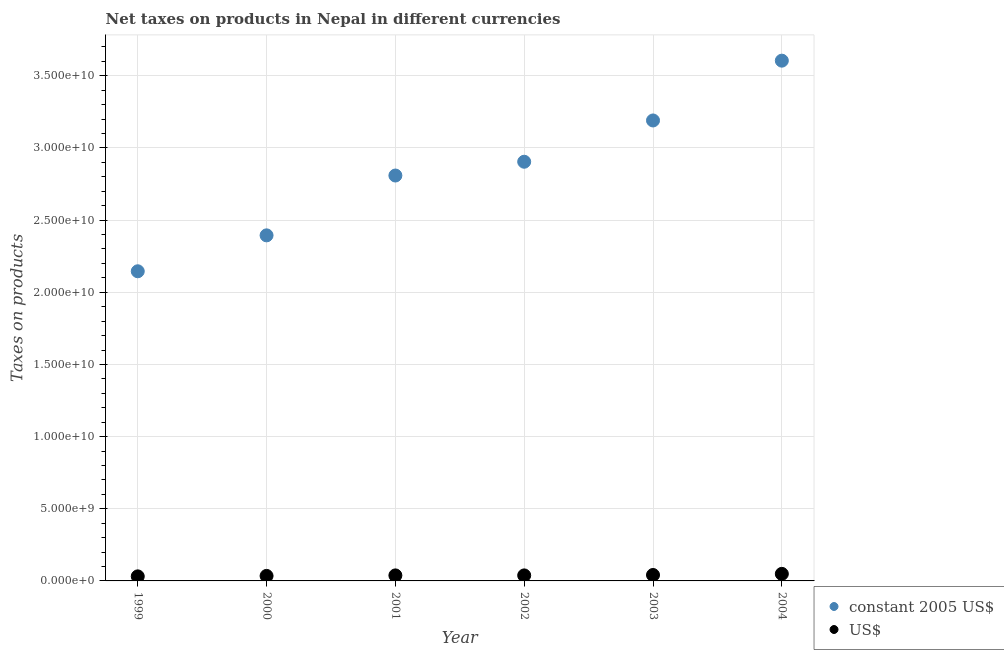Is the number of dotlines equal to the number of legend labels?
Give a very brief answer. Yes. What is the net taxes in constant 2005 us$ in 2001?
Make the answer very short. 2.81e+1. Across all years, what is the maximum net taxes in constant 2005 us$?
Your answer should be compact. 3.60e+1. Across all years, what is the minimum net taxes in us$?
Make the answer very short. 3.16e+08. In which year was the net taxes in constant 2005 us$ maximum?
Your answer should be very brief. 2004. What is the total net taxes in us$ in the graph?
Your answer should be very brief. 2.33e+09. What is the difference between the net taxes in us$ in 2002 and that in 2004?
Your answer should be very brief. -1.06e+08. What is the difference between the net taxes in constant 2005 us$ in 2000 and the net taxes in us$ in 2004?
Offer a terse response. 2.35e+1. What is the average net taxes in constant 2005 us$ per year?
Ensure brevity in your answer.  2.84e+1. In the year 2003, what is the difference between the net taxes in constant 2005 us$ and net taxes in us$?
Your answer should be compact. 3.15e+1. What is the ratio of the net taxes in us$ in 1999 to that in 2001?
Provide a short and direct response. 0.83. Is the net taxes in constant 2005 us$ in 2000 less than that in 2001?
Your answer should be compact. Yes. What is the difference between the highest and the second highest net taxes in us$?
Provide a succinct answer. 7.82e+07. What is the difference between the highest and the lowest net taxes in constant 2005 us$?
Offer a terse response. 1.46e+1. In how many years, is the net taxes in us$ greater than the average net taxes in us$ taken over all years?
Your answer should be very brief. 2. Is the sum of the net taxes in us$ in 1999 and 2002 greater than the maximum net taxes in constant 2005 us$ across all years?
Offer a terse response. No. Is the net taxes in us$ strictly greater than the net taxes in constant 2005 us$ over the years?
Provide a succinct answer. No. Is the net taxes in us$ strictly less than the net taxes in constant 2005 us$ over the years?
Offer a very short reply. Yes. How many years are there in the graph?
Make the answer very short. 6. Are the values on the major ticks of Y-axis written in scientific E-notation?
Your response must be concise. Yes. Where does the legend appear in the graph?
Your answer should be very brief. Bottom right. How are the legend labels stacked?
Keep it short and to the point. Vertical. What is the title of the graph?
Your answer should be compact. Net taxes on products in Nepal in different currencies. What is the label or title of the X-axis?
Provide a short and direct response. Year. What is the label or title of the Y-axis?
Offer a very short reply. Taxes on products. What is the Taxes on products in constant 2005 US$ in 1999?
Provide a short and direct response. 2.15e+1. What is the Taxes on products of US$ in 1999?
Provide a succinct answer. 3.16e+08. What is the Taxes on products of constant 2005 US$ in 2000?
Your response must be concise. 2.39e+1. What is the Taxes on products of US$ in 2000?
Keep it short and to the point. 3.47e+08. What is the Taxes on products in constant 2005 US$ in 2001?
Give a very brief answer. 2.81e+1. What is the Taxes on products of US$ in 2001?
Your answer should be very brief. 3.82e+08. What is the Taxes on products in constant 2005 US$ in 2002?
Provide a short and direct response. 2.90e+1. What is the Taxes on products in US$ in 2002?
Provide a succinct answer. 3.83e+08. What is the Taxes on products of constant 2005 US$ in 2003?
Provide a succinct answer. 3.19e+1. What is the Taxes on products of US$ in 2003?
Give a very brief answer. 4.10e+08. What is the Taxes on products in constant 2005 US$ in 2004?
Your answer should be compact. 3.60e+1. What is the Taxes on products of US$ in 2004?
Give a very brief answer. 4.89e+08. Across all years, what is the maximum Taxes on products of constant 2005 US$?
Give a very brief answer. 3.60e+1. Across all years, what is the maximum Taxes on products of US$?
Ensure brevity in your answer.  4.89e+08. Across all years, what is the minimum Taxes on products in constant 2005 US$?
Ensure brevity in your answer.  2.15e+1. Across all years, what is the minimum Taxes on products in US$?
Offer a very short reply. 3.16e+08. What is the total Taxes on products of constant 2005 US$ in the graph?
Your response must be concise. 1.70e+11. What is the total Taxes on products in US$ in the graph?
Your answer should be compact. 2.33e+09. What is the difference between the Taxes on products of constant 2005 US$ in 1999 and that in 2000?
Provide a short and direct response. -2.49e+09. What is the difference between the Taxes on products in US$ in 1999 and that in 2000?
Keep it short and to the point. -3.09e+07. What is the difference between the Taxes on products of constant 2005 US$ in 1999 and that in 2001?
Ensure brevity in your answer.  -6.64e+09. What is the difference between the Taxes on products in US$ in 1999 and that in 2001?
Keep it short and to the point. -6.64e+07. What is the difference between the Taxes on products in constant 2005 US$ in 1999 and that in 2002?
Your answer should be compact. -7.59e+09. What is the difference between the Taxes on products in US$ in 1999 and that in 2002?
Provide a succinct answer. -6.68e+07. What is the difference between the Taxes on products in constant 2005 US$ in 1999 and that in 2003?
Your answer should be very brief. -1.04e+1. What is the difference between the Taxes on products in US$ in 1999 and that in 2003?
Make the answer very short. -9.46e+07. What is the difference between the Taxes on products in constant 2005 US$ in 1999 and that in 2004?
Your response must be concise. -1.46e+1. What is the difference between the Taxes on products of US$ in 1999 and that in 2004?
Offer a terse response. -1.73e+08. What is the difference between the Taxes on products in constant 2005 US$ in 2000 and that in 2001?
Provide a short and direct response. -4.15e+09. What is the difference between the Taxes on products in US$ in 2000 and that in 2001?
Offer a terse response. -3.55e+07. What is the difference between the Taxes on products of constant 2005 US$ in 2000 and that in 2002?
Make the answer very short. -5.10e+09. What is the difference between the Taxes on products of US$ in 2000 and that in 2002?
Make the answer very short. -3.59e+07. What is the difference between the Taxes on products of constant 2005 US$ in 2000 and that in 2003?
Give a very brief answer. -7.96e+09. What is the difference between the Taxes on products of US$ in 2000 and that in 2003?
Your response must be concise. -6.37e+07. What is the difference between the Taxes on products of constant 2005 US$ in 2000 and that in 2004?
Your response must be concise. -1.21e+1. What is the difference between the Taxes on products of US$ in 2000 and that in 2004?
Provide a short and direct response. -1.42e+08. What is the difference between the Taxes on products in constant 2005 US$ in 2001 and that in 2002?
Ensure brevity in your answer.  -9.55e+08. What is the difference between the Taxes on products of US$ in 2001 and that in 2002?
Offer a terse response. -3.46e+05. What is the difference between the Taxes on products in constant 2005 US$ in 2001 and that in 2003?
Your answer should be very brief. -3.82e+09. What is the difference between the Taxes on products of US$ in 2001 and that in 2003?
Your response must be concise. -2.81e+07. What is the difference between the Taxes on products in constant 2005 US$ in 2001 and that in 2004?
Offer a very short reply. -7.96e+09. What is the difference between the Taxes on products in US$ in 2001 and that in 2004?
Offer a very short reply. -1.06e+08. What is the difference between the Taxes on products in constant 2005 US$ in 2002 and that in 2003?
Your response must be concise. -2.86e+09. What is the difference between the Taxes on products of US$ in 2002 and that in 2003?
Give a very brief answer. -2.78e+07. What is the difference between the Taxes on products in constant 2005 US$ in 2002 and that in 2004?
Your answer should be compact. -7.00e+09. What is the difference between the Taxes on products of US$ in 2002 and that in 2004?
Give a very brief answer. -1.06e+08. What is the difference between the Taxes on products of constant 2005 US$ in 2003 and that in 2004?
Make the answer very short. -4.14e+09. What is the difference between the Taxes on products of US$ in 2003 and that in 2004?
Provide a succinct answer. -7.82e+07. What is the difference between the Taxes on products of constant 2005 US$ in 1999 and the Taxes on products of US$ in 2000?
Make the answer very short. 2.11e+1. What is the difference between the Taxes on products in constant 2005 US$ in 1999 and the Taxes on products in US$ in 2001?
Your answer should be very brief. 2.11e+1. What is the difference between the Taxes on products of constant 2005 US$ in 1999 and the Taxes on products of US$ in 2002?
Make the answer very short. 2.11e+1. What is the difference between the Taxes on products in constant 2005 US$ in 1999 and the Taxes on products in US$ in 2003?
Make the answer very short. 2.10e+1. What is the difference between the Taxes on products of constant 2005 US$ in 1999 and the Taxes on products of US$ in 2004?
Keep it short and to the point. 2.10e+1. What is the difference between the Taxes on products of constant 2005 US$ in 2000 and the Taxes on products of US$ in 2001?
Give a very brief answer. 2.36e+1. What is the difference between the Taxes on products of constant 2005 US$ in 2000 and the Taxes on products of US$ in 2002?
Offer a terse response. 2.36e+1. What is the difference between the Taxes on products in constant 2005 US$ in 2000 and the Taxes on products in US$ in 2003?
Your response must be concise. 2.35e+1. What is the difference between the Taxes on products in constant 2005 US$ in 2000 and the Taxes on products in US$ in 2004?
Provide a succinct answer. 2.35e+1. What is the difference between the Taxes on products of constant 2005 US$ in 2001 and the Taxes on products of US$ in 2002?
Your answer should be compact. 2.77e+1. What is the difference between the Taxes on products of constant 2005 US$ in 2001 and the Taxes on products of US$ in 2003?
Ensure brevity in your answer.  2.77e+1. What is the difference between the Taxes on products in constant 2005 US$ in 2001 and the Taxes on products in US$ in 2004?
Provide a short and direct response. 2.76e+1. What is the difference between the Taxes on products in constant 2005 US$ in 2002 and the Taxes on products in US$ in 2003?
Offer a terse response. 2.86e+1. What is the difference between the Taxes on products in constant 2005 US$ in 2002 and the Taxes on products in US$ in 2004?
Your answer should be compact. 2.86e+1. What is the difference between the Taxes on products in constant 2005 US$ in 2003 and the Taxes on products in US$ in 2004?
Your answer should be very brief. 3.14e+1. What is the average Taxes on products in constant 2005 US$ per year?
Make the answer very short. 2.84e+1. What is the average Taxes on products in US$ per year?
Your answer should be compact. 3.88e+08. In the year 1999, what is the difference between the Taxes on products of constant 2005 US$ and Taxes on products of US$?
Keep it short and to the point. 2.11e+1. In the year 2000, what is the difference between the Taxes on products of constant 2005 US$ and Taxes on products of US$?
Your response must be concise. 2.36e+1. In the year 2001, what is the difference between the Taxes on products in constant 2005 US$ and Taxes on products in US$?
Your response must be concise. 2.77e+1. In the year 2002, what is the difference between the Taxes on products in constant 2005 US$ and Taxes on products in US$?
Offer a very short reply. 2.87e+1. In the year 2003, what is the difference between the Taxes on products in constant 2005 US$ and Taxes on products in US$?
Your response must be concise. 3.15e+1. In the year 2004, what is the difference between the Taxes on products of constant 2005 US$ and Taxes on products of US$?
Your answer should be compact. 3.56e+1. What is the ratio of the Taxes on products in constant 2005 US$ in 1999 to that in 2000?
Provide a succinct answer. 0.9. What is the ratio of the Taxes on products in US$ in 1999 to that in 2000?
Offer a terse response. 0.91. What is the ratio of the Taxes on products of constant 2005 US$ in 1999 to that in 2001?
Your answer should be compact. 0.76. What is the ratio of the Taxes on products of US$ in 1999 to that in 2001?
Make the answer very short. 0.83. What is the ratio of the Taxes on products of constant 2005 US$ in 1999 to that in 2002?
Keep it short and to the point. 0.74. What is the ratio of the Taxes on products in US$ in 1999 to that in 2002?
Your answer should be compact. 0.83. What is the ratio of the Taxes on products in constant 2005 US$ in 1999 to that in 2003?
Provide a succinct answer. 0.67. What is the ratio of the Taxes on products in US$ in 1999 to that in 2003?
Offer a very short reply. 0.77. What is the ratio of the Taxes on products in constant 2005 US$ in 1999 to that in 2004?
Offer a terse response. 0.6. What is the ratio of the Taxes on products in US$ in 1999 to that in 2004?
Provide a succinct answer. 0.65. What is the ratio of the Taxes on products in constant 2005 US$ in 2000 to that in 2001?
Provide a succinct answer. 0.85. What is the ratio of the Taxes on products in US$ in 2000 to that in 2001?
Offer a terse response. 0.91. What is the ratio of the Taxes on products of constant 2005 US$ in 2000 to that in 2002?
Ensure brevity in your answer.  0.82. What is the ratio of the Taxes on products of US$ in 2000 to that in 2002?
Provide a short and direct response. 0.91. What is the ratio of the Taxes on products of constant 2005 US$ in 2000 to that in 2003?
Keep it short and to the point. 0.75. What is the ratio of the Taxes on products in US$ in 2000 to that in 2003?
Offer a terse response. 0.84. What is the ratio of the Taxes on products of constant 2005 US$ in 2000 to that in 2004?
Provide a short and direct response. 0.66. What is the ratio of the Taxes on products in US$ in 2000 to that in 2004?
Give a very brief answer. 0.71. What is the ratio of the Taxes on products of constant 2005 US$ in 2001 to that in 2002?
Your answer should be compact. 0.97. What is the ratio of the Taxes on products of constant 2005 US$ in 2001 to that in 2003?
Your answer should be very brief. 0.88. What is the ratio of the Taxes on products of US$ in 2001 to that in 2003?
Provide a succinct answer. 0.93. What is the ratio of the Taxes on products in constant 2005 US$ in 2001 to that in 2004?
Your response must be concise. 0.78. What is the ratio of the Taxes on products in US$ in 2001 to that in 2004?
Your response must be concise. 0.78. What is the ratio of the Taxes on products of constant 2005 US$ in 2002 to that in 2003?
Your answer should be very brief. 0.91. What is the ratio of the Taxes on products of US$ in 2002 to that in 2003?
Offer a terse response. 0.93. What is the ratio of the Taxes on products of constant 2005 US$ in 2002 to that in 2004?
Your answer should be very brief. 0.81. What is the ratio of the Taxes on products of US$ in 2002 to that in 2004?
Your response must be concise. 0.78. What is the ratio of the Taxes on products in constant 2005 US$ in 2003 to that in 2004?
Give a very brief answer. 0.89. What is the ratio of the Taxes on products of US$ in 2003 to that in 2004?
Make the answer very short. 0.84. What is the difference between the highest and the second highest Taxes on products in constant 2005 US$?
Make the answer very short. 4.14e+09. What is the difference between the highest and the second highest Taxes on products in US$?
Give a very brief answer. 7.82e+07. What is the difference between the highest and the lowest Taxes on products in constant 2005 US$?
Your answer should be compact. 1.46e+1. What is the difference between the highest and the lowest Taxes on products of US$?
Provide a succinct answer. 1.73e+08. 